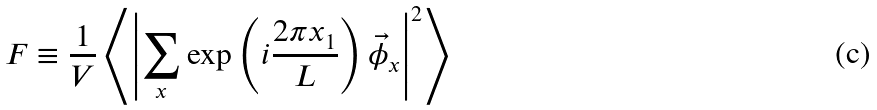Convert formula to latex. <formula><loc_0><loc_0><loc_500><loc_500>F \equiv \frac { 1 } { V } \left \langle \left | \sum _ { x } \exp \left ( i \frac { 2 \pi x _ { 1 } } { L } \right ) \vec { \phi } _ { x } \right | ^ { 2 } \right \rangle</formula> 